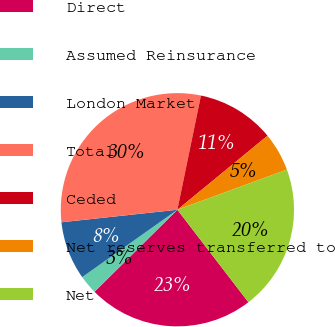<chart> <loc_0><loc_0><loc_500><loc_500><pie_chart><fcel>Direct<fcel>Assumed Reinsurance<fcel>London Market<fcel>Total<fcel>Ceded<fcel>Net reserves transferred to<fcel>Net<nl><fcel>23.0%<fcel>2.62%<fcel>8.09%<fcel>29.95%<fcel>10.82%<fcel>5.35%<fcel>20.17%<nl></chart> 